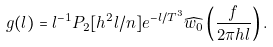Convert formula to latex. <formula><loc_0><loc_0><loc_500><loc_500>g ( l ) = l ^ { - 1 } P _ { 2 } [ h ^ { 2 } l / n ] e ^ { - l / T ^ { 3 } } \widehat { w _ { 0 } } \left ( \frac { f } { 2 \pi h l } \right ) .</formula> 